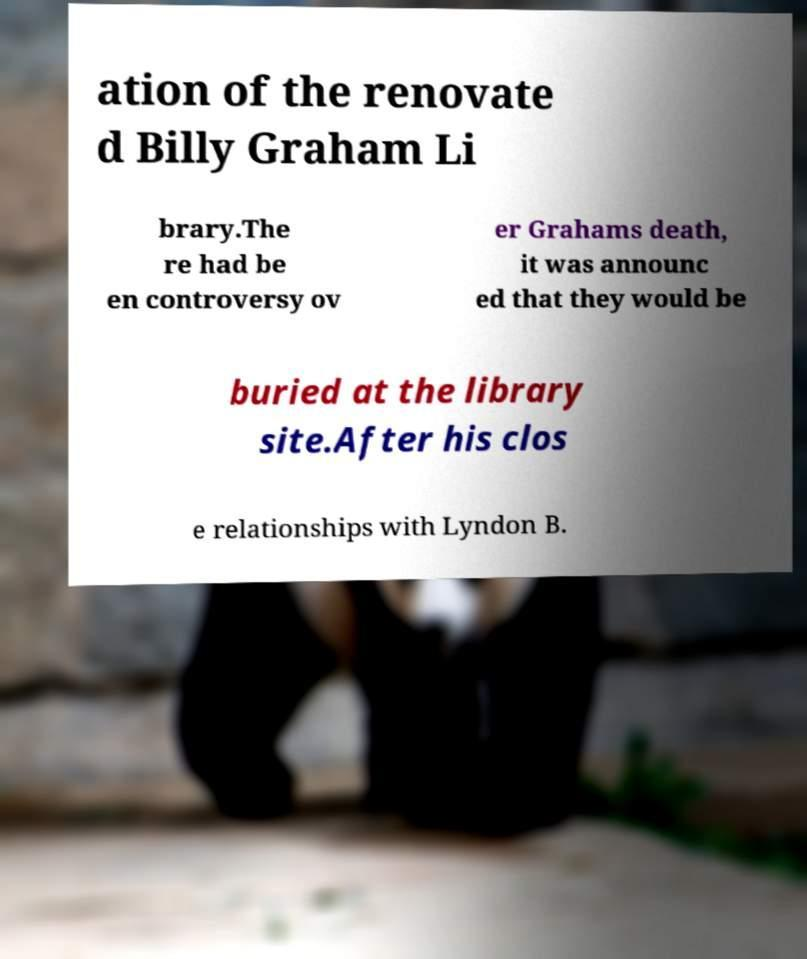For documentation purposes, I need the text within this image transcribed. Could you provide that? ation of the renovate d Billy Graham Li brary.The re had be en controversy ov er Grahams death, it was announc ed that they would be buried at the library site.After his clos e relationships with Lyndon B. 